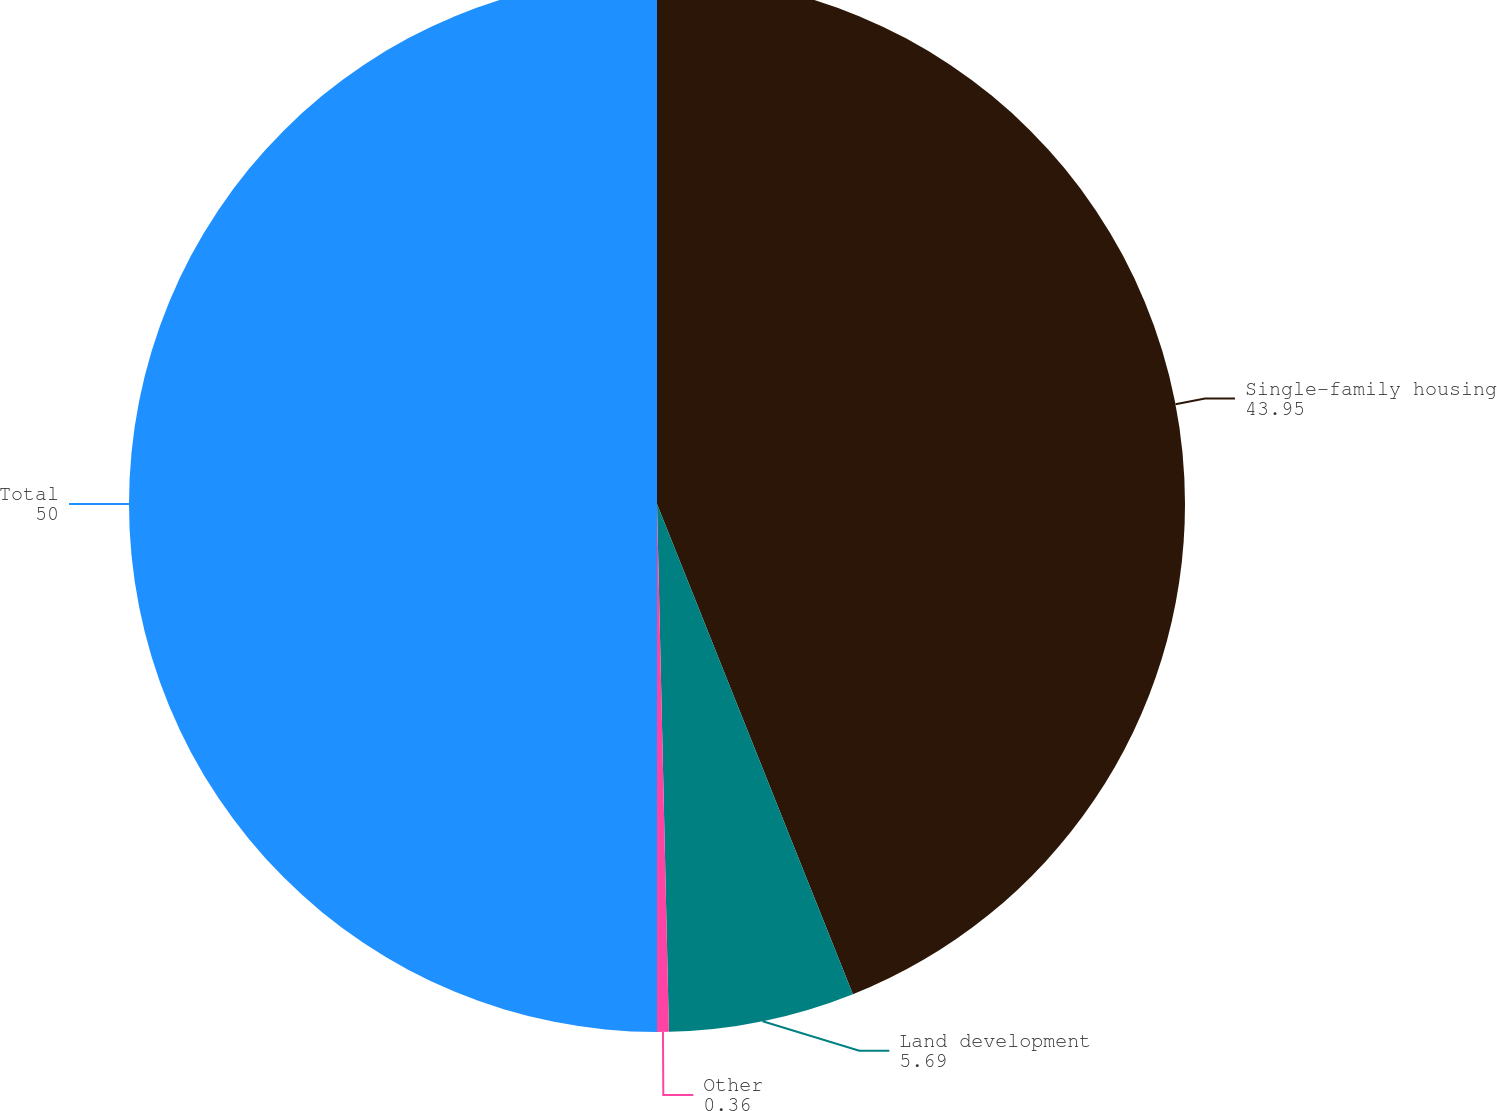<chart> <loc_0><loc_0><loc_500><loc_500><pie_chart><fcel>Single-family housing<fcel>Land development<fcel>Other<fcel>Total<nl><fcel>43.95%<fcel>5.69%<fcel>0.36%<fcel>50.0%<nl></chart> 